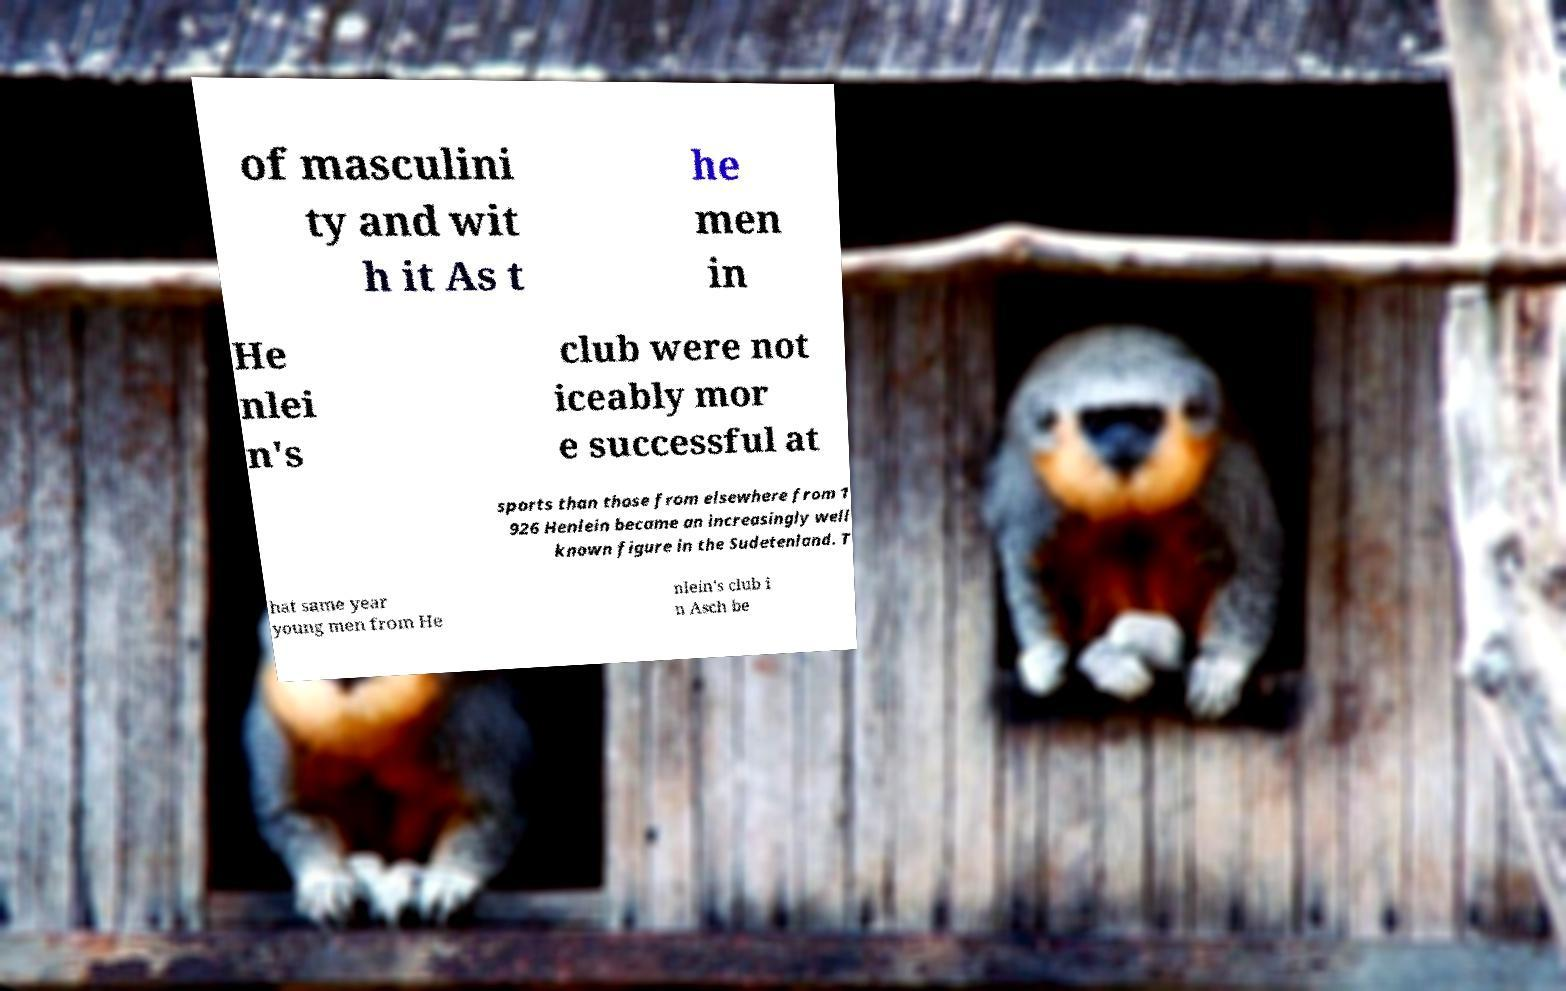Could you assist in decoding the text presented in this image and type it out clearly? of masculini ty and wit h it As t he men in He nlei n's club were not iceably mor e successful at sports than those from elsewhere from 1 926 Henlein became an increasingly well known figure in the Sudetenland. T hat same year young men from He nlein's club i n Asch be 